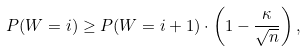Convert formula to latex. <formula><loc_0><loc_0><loc_500><loc_500>P ( W = i ) \geq P ( W = i + 1 ) \cdot \left ( 1 - \frac { \kappa } { \sqrt { n } } \right ) ,</formula> 